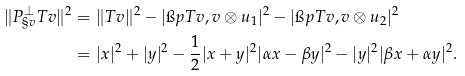Convert formula to latex. <formula><loc_0><loc_0><loc_500><loc_500>\| P _ { \S v } ^ { \perp } T v \| ^ { 2 } & = \| T v \| ^ { 2 } - | \i p { T v , v \otimes u _ { 1 } } | ^ { 2 } - | \i p { T v , v \otimes u _ { 2 } } | ^ { 2 } \\ & = | x | ^ { 2 } + | y | ^ { 2 } - \frac { 1 } { 2 } | x + y | ^ { 2 } | \alpha x - \beta y | ^ { 2 } - | y | ^ { 2 } | \beta x + \alpha y | ^ { 2 } .</formula> 